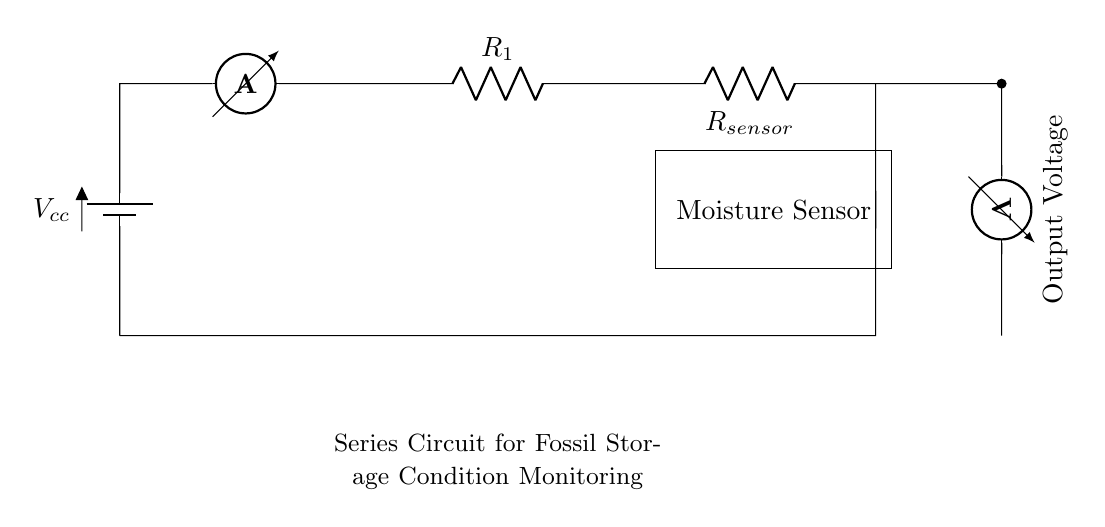What type of circuit is depicted? The circuit is a series circuit, shown by the configuration where components are connected end-to-end, forming a single path for current flow.
Answer: series circuit What is the voltage source in the circuit? The voltage source is indicated by the battery symbol in the schematic, providing the necessary power for the circuit's operation.
Answer: Vcc What component directly measures moisture? The moisture sensor is identified as a labeled component in the circuit representation, specifically used to detect humidity levels affecting the fossils.
Answer: Moisture Sensor How many resistors are present in the circuit? Two resistors are visible, one labeled R1 in series with another labeled Rsensor, which affects the overall resistance in the series configuration.
Answer: 2 What is the output from the moisture sensor? The output is represented as voltage measured by the voltmeter component connected to the moisture sensor, indicating the sensor's readings based on moisture detection.
Answer: Output Voltage If resistance R1 is 10 ohms and Rsensor is 5 ohms, what is the total resistance? To find the total resistance in a series circuit, we sum the resistances: Rtotal = R1 + Rsensor = 10 ohms + 5 ohms = 15 ohms.
Answer: 15 ohms 